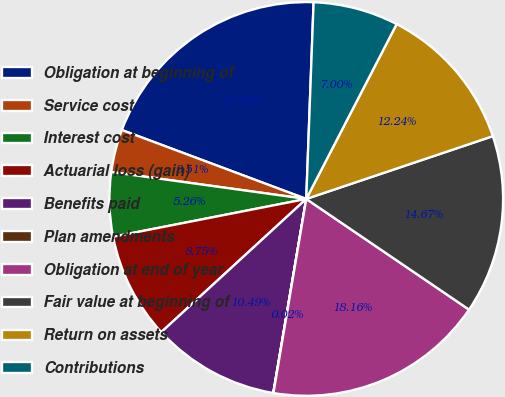<chart> <loc_0><loc_0><loc_500><loc_500><pie_chart><fcel>Obligation at beginning of<fcel>Service cost<fcel>Interest cost<fcel>Actuarial loss (gain)<fcel>Benefits paid<fcel>Plan amendments<fcel>Obligation at end of year<fcel>Fair value at beginning of<fcel>Return on assets<fcel>Contributions<nl><fcel>19.9%<fcel>3.51%<fcel>5.26%<fcel>8.75%<fcel>10.49%<fcel>0.02%<fcel>18.16%<fcel>14.67%<fcel>12.24%<fcel>7.0%<nl></chart> 